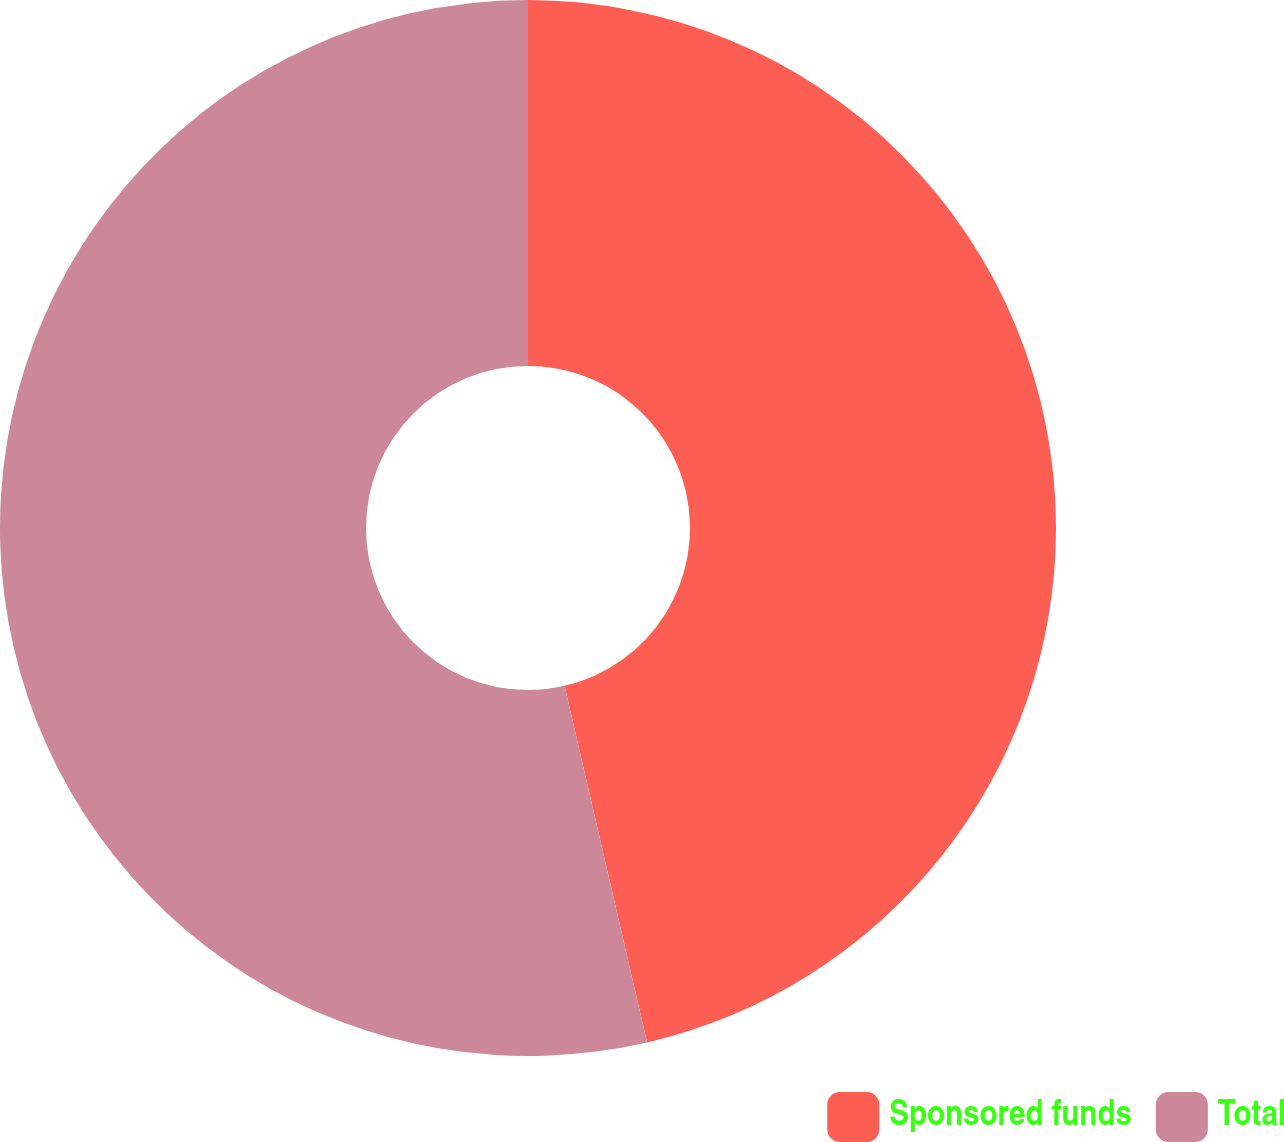Convert chart to OTSL. <chart><loc_0><loc_0><loc_500><loc_500><pie_chart><fcel>Sponsored funds<fcel>Total<nl><fcel>46.38%<fcel>53.62%<nl></chart> 